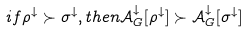Convert formula to latex. <formula><loc_0><loc_0><loc_500><loc_500>i f \rho ^ { \downarrow } \succ \sigma ^ { \downarrow } , t h e n \mathcal { A } ^ { \downarrow } _ { G } [ \rho ^ { \downarrow } ] \succ \mathcal { A } ^ { \downarrow } _ { G } [ \sigma ^ { \downarrow } ]</formula> 